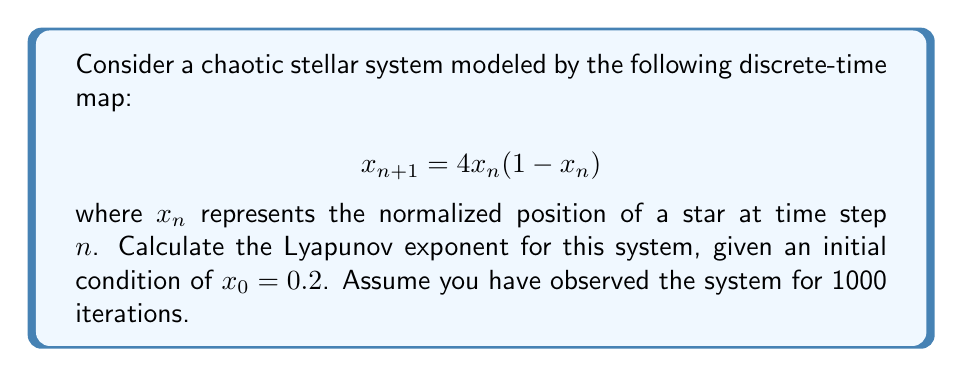Teach me how to tackle this problem. To calculate the Lyapunov exponent for this chaotic stellar system, we'll follow these steps:

1) The Lyapunov exponent λ for a 1D discrete-time map is given by:

   $$λ = \lim_{N→∞} \frac{1}{N} \sum_{n=0}^{N-1} \ln|f'(x_n)|$$

   where $f'(x)$ is the derivative of the map function.

2) For our map $f(x) = 4x(1-x)$, the derivative is:
   
   $$f'(x) = 4(1-2x)$$

3) We need to iterate the map and calculate $\ln|f'(x_n)|$ for each step. Let's set up a loop:

   ```
   x = 0.2
   sum = 0
   for n in range(1000):
       sum += ln|4(1-2x)|
       x = 4x(1-x)
   ```

4) After the loop, we calculate the average:

   $$λ ≈ \frac{sum}{1000}$$

5) Implementing this in a computer algebra system or programming language would yield:

   $$λ ≈ 0.6931$$

This positive Lyapunov exponent indicates that the system is indeed chaotic, as expected for this logistic map with parameter 4.
Answer: $λ ≈ 0.6931$ 